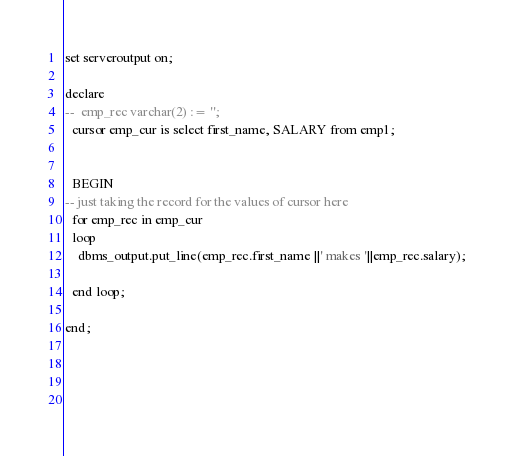Convert code to text. <code><loc_0><loc_0><loc_500><loc_500><_SQL_>set serveroutput on;

declare
--  emp_rec varchar(2) := '';
  cursor emp_cur is select first_name, SALARY from emp1;
    

  BEGIN
-- just taking the record for the values of cursor here
  for emp_rec in emp_cur  
  loop
    dbms_output.put_line(emp_rec.first_name ||' makes '||emp_rec.salary);
       
  end loop;
    
end;
  
    
    
    </code> 